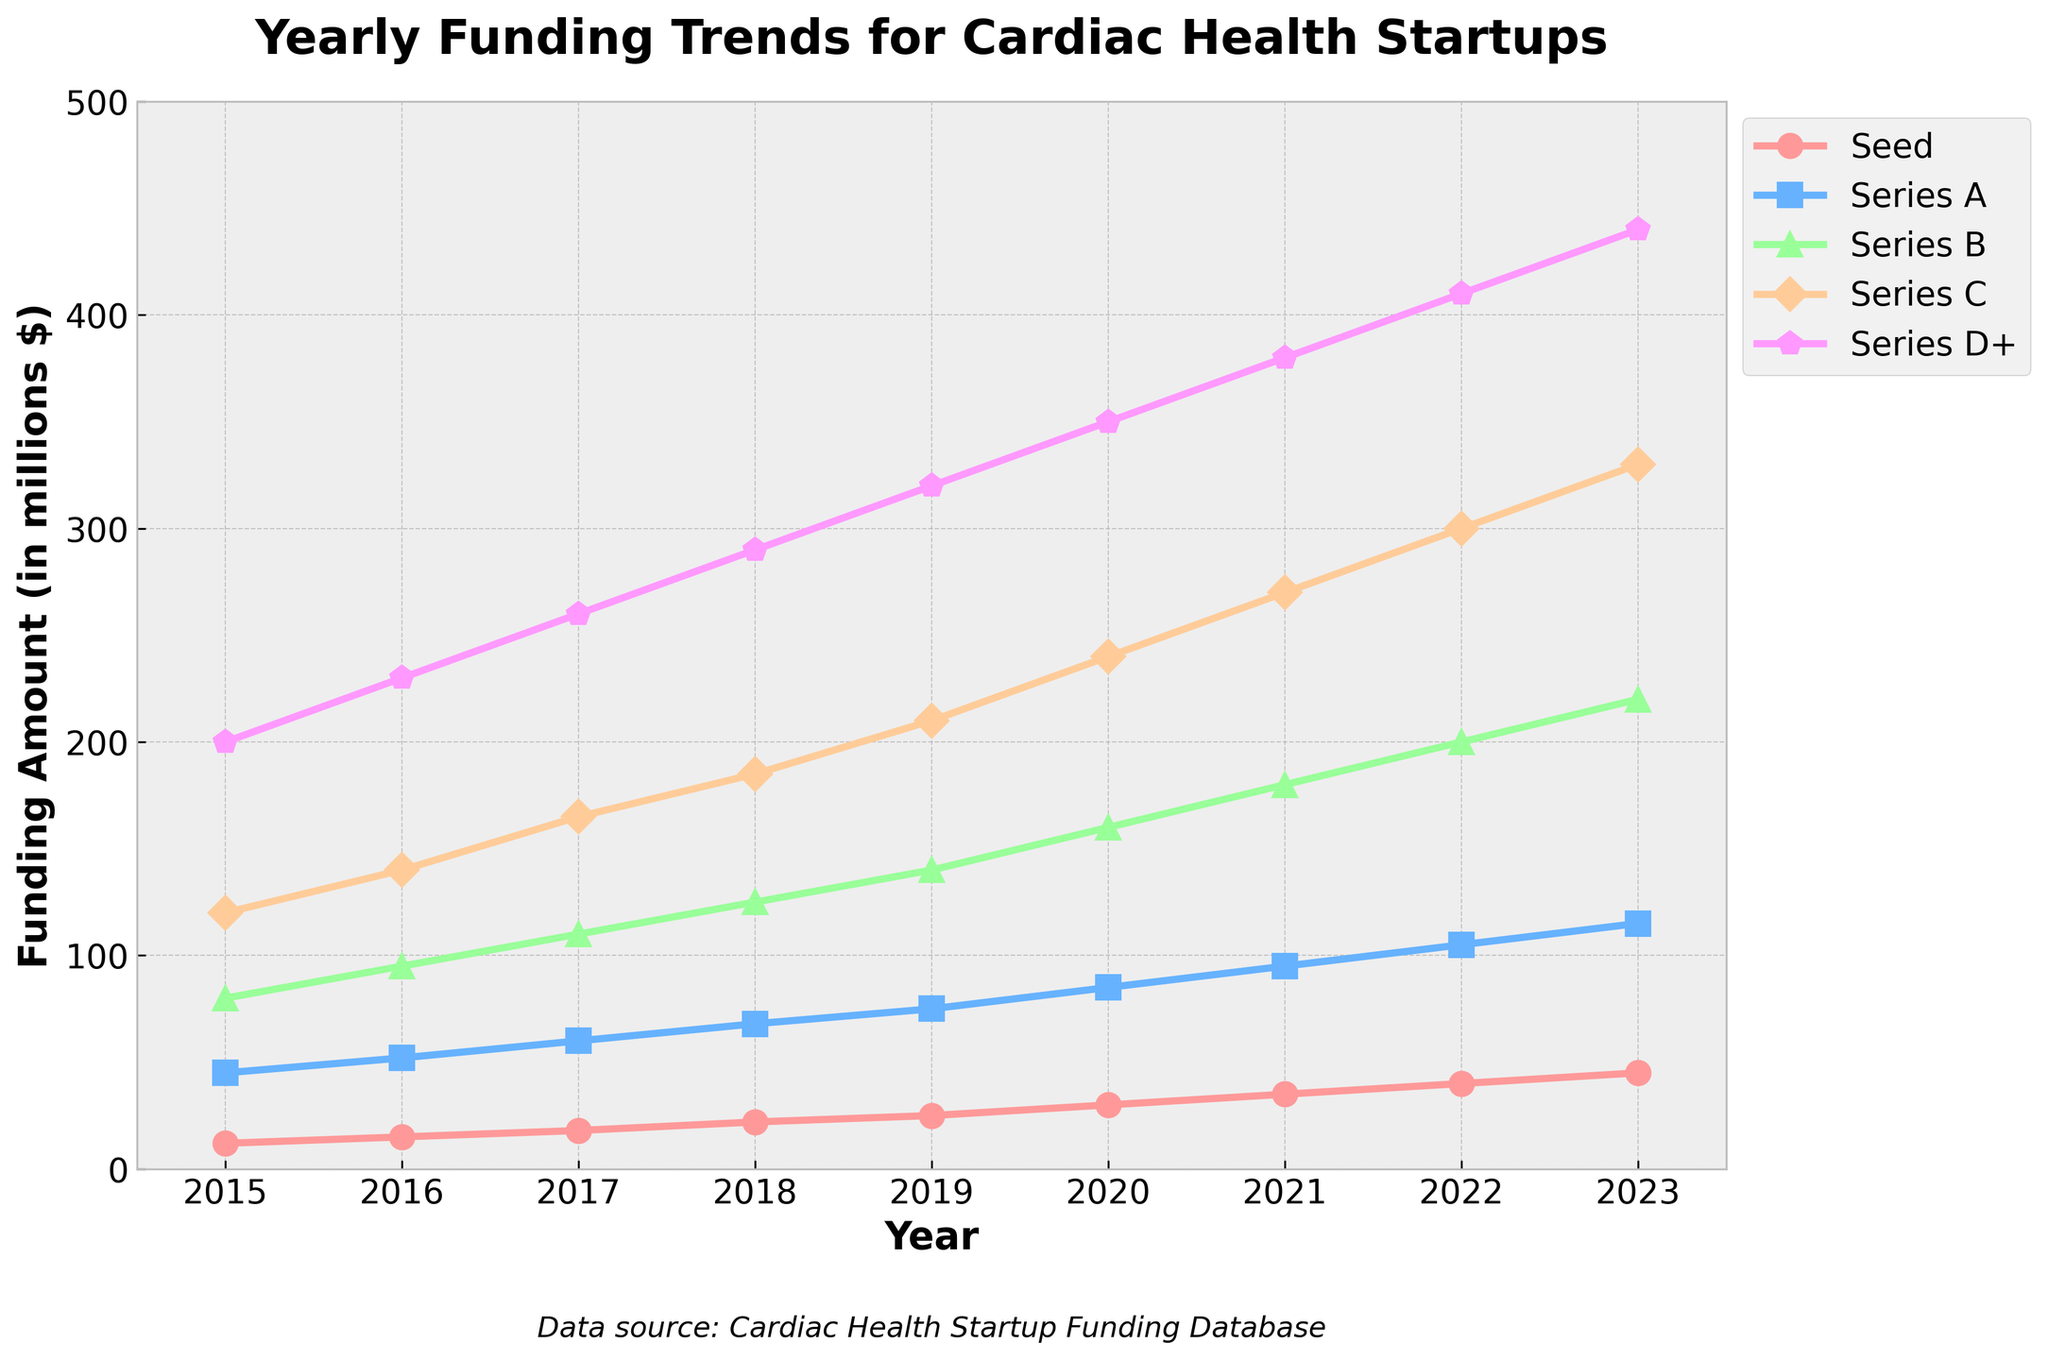What's the total funding for Seed and Series A stages in 2020? Seed funding in 2020 is 30 million dollars. Series A funding in 2020 is 85 million dollars. The total is 30 + 85 = 115 million dollars.
Answer: 115 million dollars Which stage saw the greatest increase in funding from 2017 to 2018? Series C funding increased from 165 million dollars to 185 million dollars, a difference of 20 million dollars, which is the highest among all stages for that period.
Answer: Series C What color is used to represent Series B funding? The line representing Series B funding is green in color.
Answer: Green Between which two consecutive years did Series D+ funding witness the largest increase? Comparing each consecutive year from 2015 to 2023: 2015 to 2016 (30 million), 2016 to 2017 (30 million), 2017 to 2018 (30 million), 2018 to 2019 (30 million), 2019 to 2020 (30 million), 2020 to 2021 (30 million), 2021 to 2022 (30 million), and 2022 to 2023 (30 million). All increases are equal, so no two years have the largest single increase; they all increased by 30 million dollars each year.
Answer: 2015 to 2016 (as representative) What is the average yearly Series A funding from 2018 to 2022? Series A funding for 2018: 68 million, 2019: 75 million, 2020: 85 million, 2021: 95 million, 2022: 105 million. The average is (68 + 75 + 85 + 95 + 105) / 5 = 428 / 5 = 85.6 million dollars.
Answer: 85.6 million dollars In which year did Seed funding surpass 20 million dollars? Seed funding surpassed 20 million dollars in 2018 with 22 million dollars.
Answer: 2018 How much more funding did Series D+ receive compared to Series C in 2023? Series D+ in 2023 received 440 million dollars, while Series C received 330 million dollars. The difference is 440 - 330 = 110 million dollars.
Answer: 110 million dollars What visual marker shape is used to represent Series C? The line for Series C is represented by the marker shape 'D' (diamond).
Answer: Diamond Between 2015 and 2023, which stage consistently saw an increase in funding each year? Examining each year, it is evident that all stages (Seed, Series A, Series B, Series C, and Series D+) consistently saw funding increases each year from 2015 to 2023.
Answer: All stages Which year showed the highest overall funding sum for all stages? Calculating the sum for each year: 2015 (457 million), 2016 (532 million), 2017 (613 million), 2018 (690 million), 2019 (770 million), 2020 (865 million), 2021 (960 million), 2022 (1055 million), 2023 (1150 million). 2023 shows the highest funding total at 1150 million dollars.
Answer: 2023 